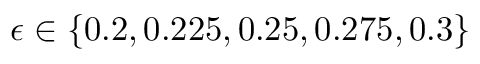<formula> <loc_0><loc_0><loc_500><loc_500>\epsilon \in \{ 0 . 2 , 0 . 2 2 5 , 0 . 2 5 , 0 . 2 7 5 , 0 . 3 \}</formula> 